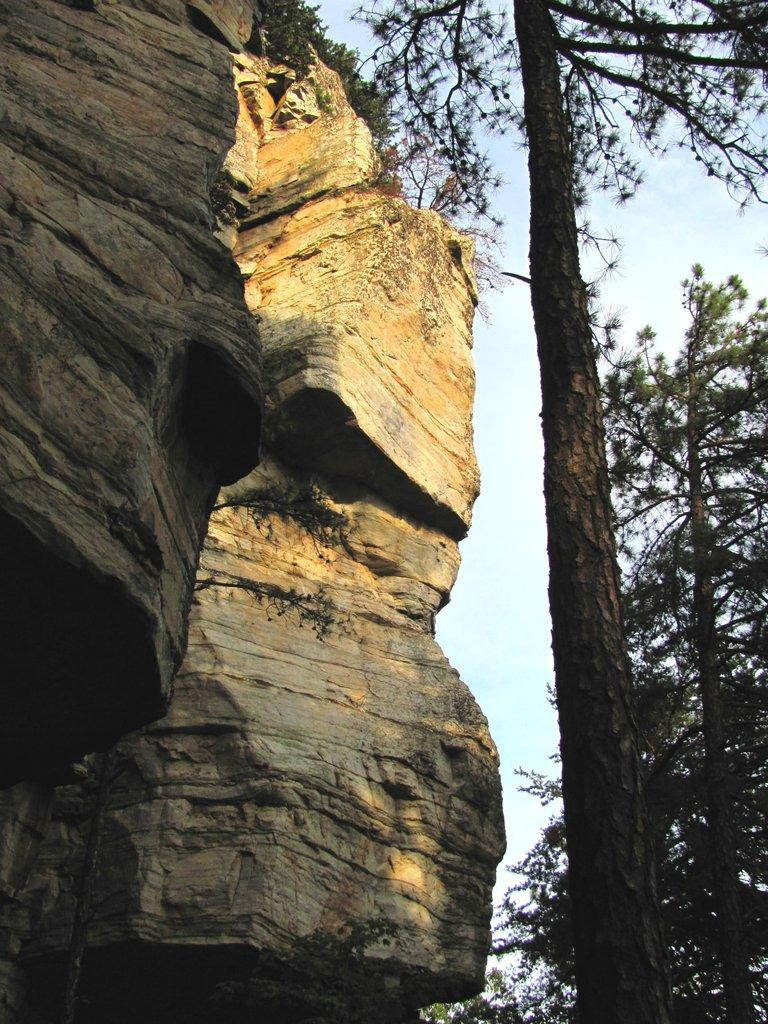What type of natural elements can be seen in the image? There are rocks and trees visible in the image. What is visible at the top of the image? The sky is visible at the top of the image. What route is the beef taking in the image? There is no beef or route present in the image. Can you tell me who is involved in the argument in the image? There is no argument or people present in the image. 